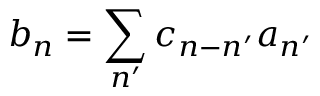<formula> <loc_0><loc_0><loc_500><loc_500>b _ { n } = \sum _ { n ^ { \prime } } c _ { n - n ^ { \prime } } a _ { n ^ { \prime } }</formula> 